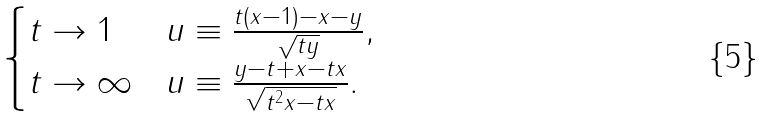Convert formula to latex. <formula><loc_0><loc_0><loc_500><loc_500>\begin{cases} t \rightarrow 1 & u \equiv \frac { t \left ( x - 1 \right ) - x - y } { { \sqrt { t y } } } , \\ t \rightarrow \infty & u \equiv \frac { y - t + x - t x } { \sqrt { t ^ { 2 } x - t x } } . \end{cases}</formula> 